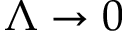<formula> <loc_0><loc_0><loc_500><loc_500>\Lambda \rightarrow 0</formula> 